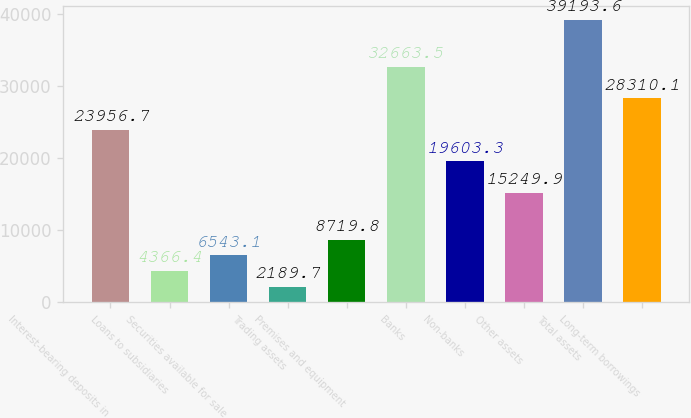Convert chart. <chart><loc_0><loc_0><loc_500><loc_500><bar_chart><fcel>Interest-bearing deposits in<fcel>Loans to subsidiaries<fcel>Securities available for sale<fcel>Trading assets<fcel>Premises and equipment<fcel>Banks<fcel>Non-banks<fcel>Other assets<fcel>Total assets<fcel>Long-term borrowings<nl><fcel>23956.7<fcel>4366.4<fcel>6543.1<fcel>2189.7<fcel>8719.8<fcel>32663.5<fcel>19603.3<fcel>15249.9<fcel>39193.6<fcel>28310.1<nl></chart> 